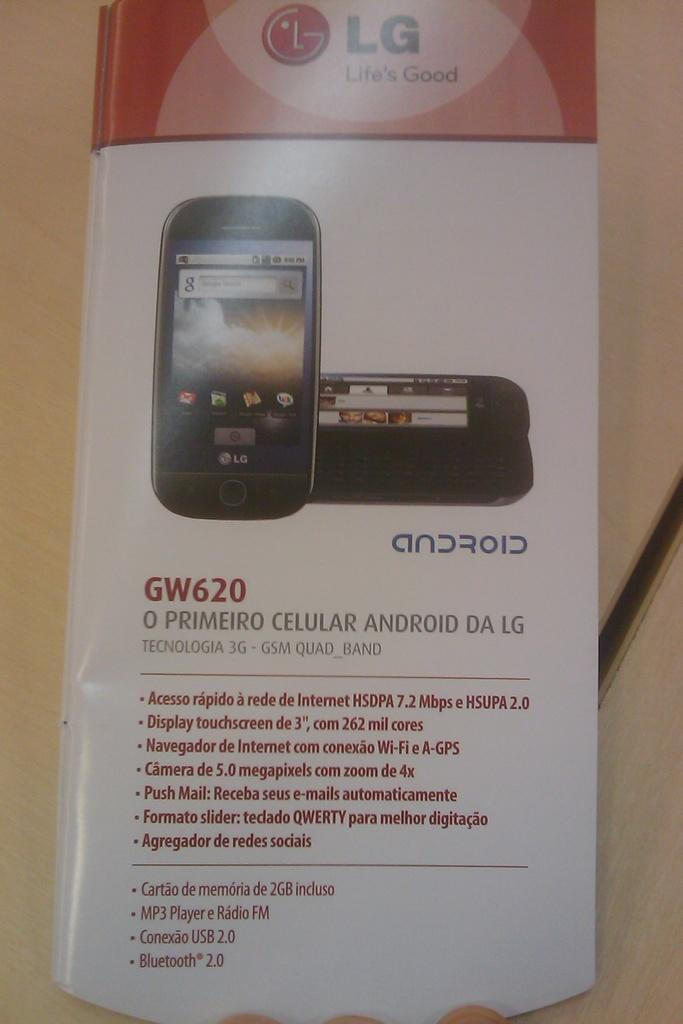<image>
Write a terse but informative summary of the picture. The box has a picture of the GW620 android cell phone. 